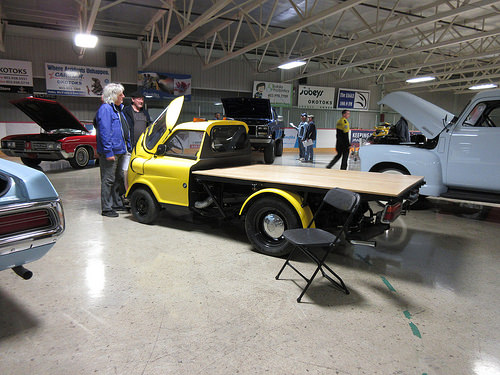<image>
Can you confirm if the truck is on the chair? No. The truck is not positioned on the chair. They may be near each other, but the truck is not supported by or resting on top of the chair. Is there a classic car above the sign? No. The classic car is not positioned above the sign. The vertical arrangement shows a different relationship. 